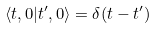<formula> <loc_0><loc_0><loc_500><loc_500>\langle t , 0 | t ^ { \prime } , 0 \rangle = \delta ( t - t ^ { \prime } )</formula> 